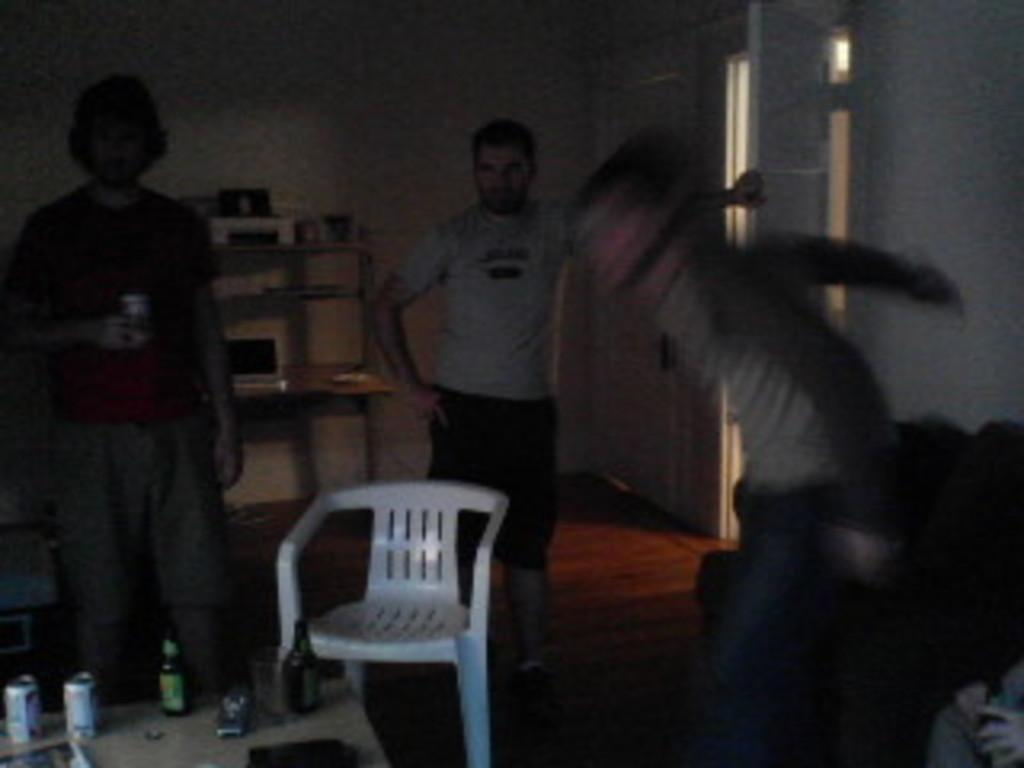How many people are present in the room? There are three people in the room. What are the people doing in the room? The people are standing in front of a table. What items can be seen on the table? There are tins and bottles on the table. What furniture is present in the room besides the table? There is a chair and a desk in the room. What type of body is visible in the image? There is no body present in the image; it features three people standing in front of a table. What color is the yarn used to create the patterns on the bottles? There is no yarn present in the image, and the bottles do not have any patterns. 